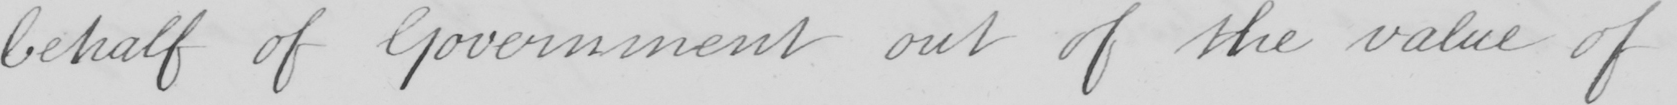Can you read and transcribe this handwriting? behalf of Government out of the value of 